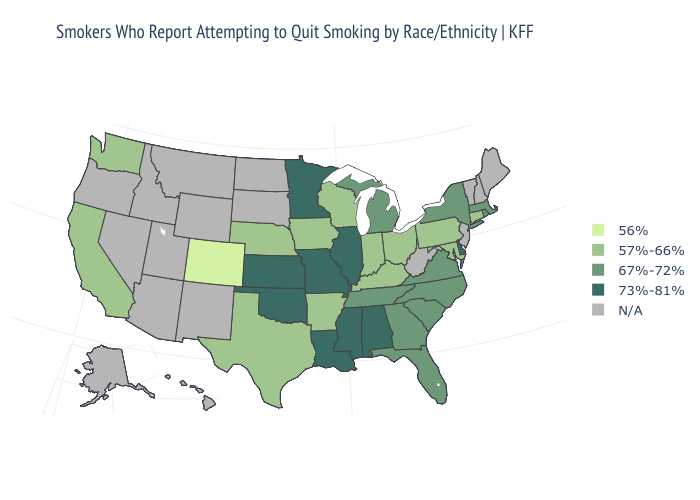What is the highest value in the West ?
Answer briefly. 57%-66%. Name the states that have a value in the range N/A?
Quick response, please. Alaska, Arizona, Hawaii, Idaho, Maine, Montana, Nevada, New Hampshire, New Jersey, New Mexico, North Dakota, Oregon, South Dakota, Utah, Vermont, West Virginia, Wyoming. Does Wisconsin have the highest value in the USA?
Keep it brief. No. Among the states that border Arizona , which have the lowest value?
Short answer required. Colorado. What is the lowest value in states that border Alabama?
Be succinct. 67%-72%. Name the states that have a value in the range 57%-66%?
Short answer required. Arkansas, California, Connecticut, Indiana, Iowa, Kentucky, Maryland, Nebraska, Ohio, Pennsylvania, Texas, Washington, Wisconsin. Among the states that border Louisiana , does Mississippi have the lowest value?
Keep it brief. No. Does Colorado have the lowest value in the USA?
Keep it brief. Yes. Name the states that have a value in the range N/A?
Give a very brief answer. Alaska, Arizona, Hawaii, Idaho, Maine, Montana, Nevada, New Hampshire, New Jersey, New Mexico, North Dakota, Oregon, South Dakota, Utah, Vermont, West Virginia, Wyoming. Name the states that have a value in the range 56%?
Be succinct. Colorado. Does the map have missing data?
Keep it brief. Yes. What is the value of Vermont?
Quick response, please. N/A. Among the states that border Texas , which have the highest value?
Concise answer only. Louisiana, Oklahoma. How many symbols are there in the legend?
Quick response, please. 5. 